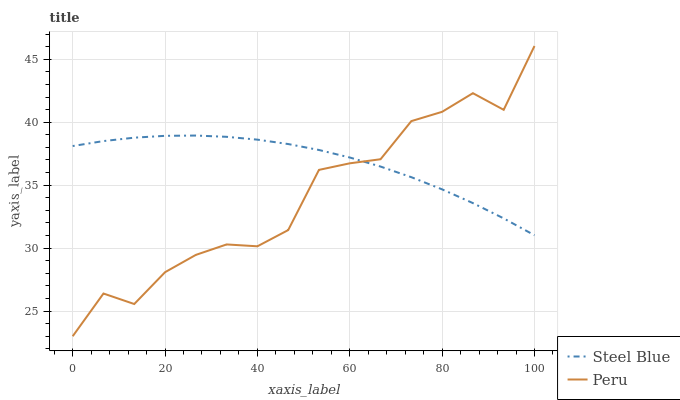Does Peru have the maximum area under the curve?
Answer yes or no. No. Is Peru the smoothest?
Answer yes or no. No. 